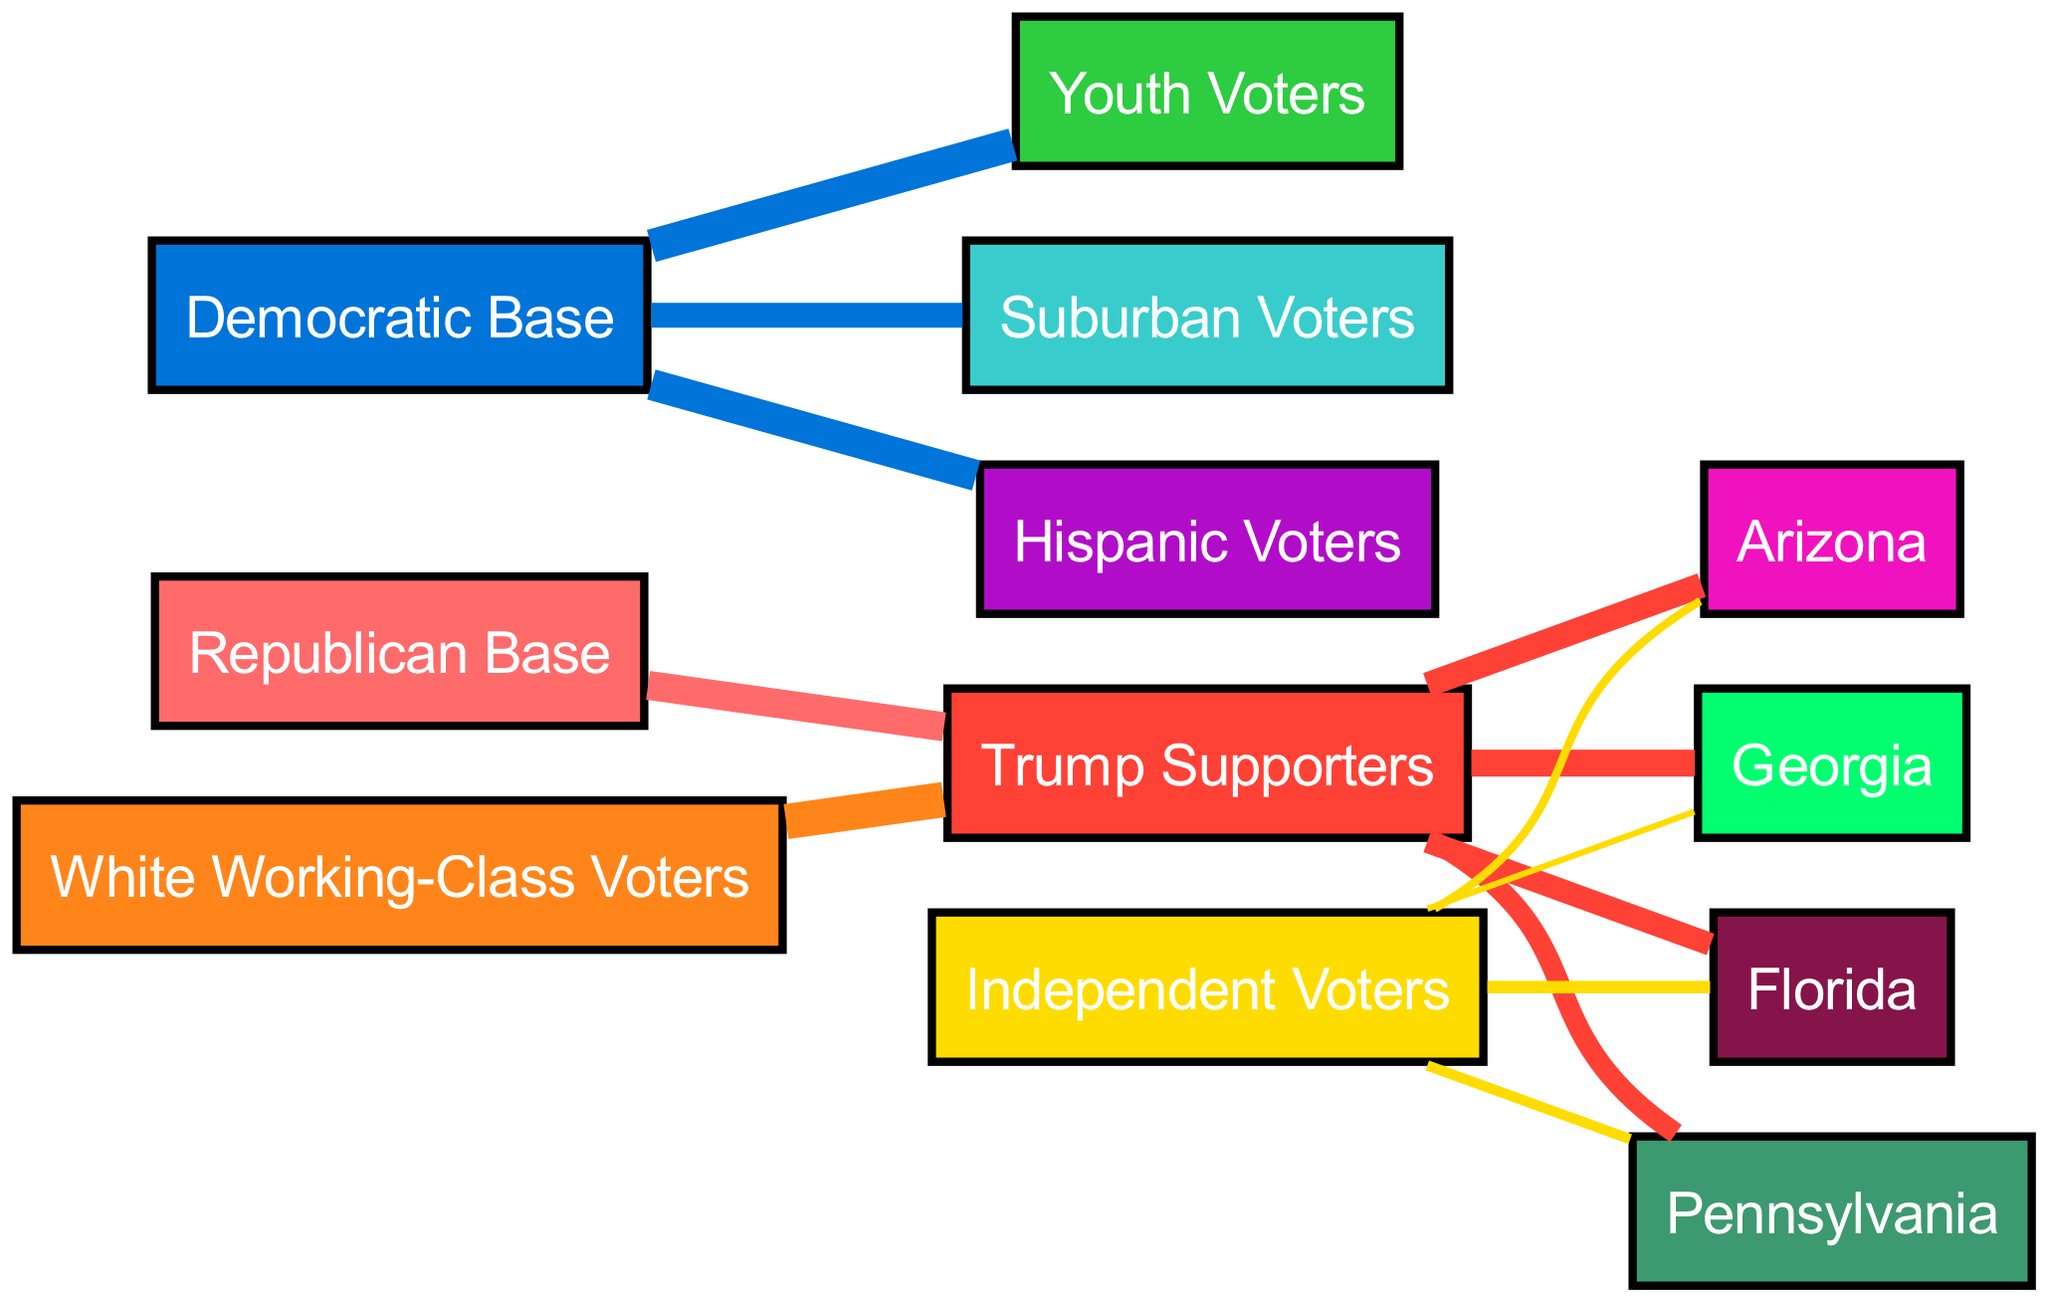What percentage of the Republican Base supports Trump Supporters? The diagram indicates a flow from the "Republican Base" to "Trump Supporters" with a value of 70, meaning 70% of the Republican Base supports Trump Supporters.
Answer: 70 How many key swing states are represented in this diagram? The nodes for key swing states are Florida, Pennsylvania, Arizona, and Georgia, totaling four states represented in the diagram.
Answer: 4 Which group has the highest flow to Florida from Trump Supporters? The flow from "Trump Supporters" to "Florida" is denoted by a value of 55, indicating that the highest support going to Florida from Trump Supporters comes from this group.
Answer: Trump Supporters What is the flow value of Independent Voters to Georgia? The value shown in the diagram from "Independent Voters" to "Georgia" is 15, indicating that 15% of Independent Voters show this flow to Georgia.
Answer: 15 Which demographic has the strongest support for the Democratic Base? The diagram indicates "Youth Voters," "Hispanic Voters," and "Suburban Voters" all flowing from the "Democratic Base." Among these, "Youth Voters" has the highest flow at 80.
Answer: Youth Voters Which demographic has the highest flow to Trump Supporters? The strongest demographic support for "Trump Supporters" comes from "White Working-Class Voters," with a very high flow value of 85, indicating this is the highest compared to other demographics.
Answer: White Working-Class Voters What is the total flow of Trump Supporters to Georgia? The diagram indicates a flow of 65 from "Trump Supporters" to "Georgia," showing the amount directly connecting these two nodes.
Answer: 65 What color represents Hispanic Voters in the diagram? Referring to the color scheme in the diagram, "Hispanic Voters" is represented in purple (#B10DC9).
Answer: Purple What is the combined value of support from Independent Voters to all swing states? The values from Independent Voters to Florida (30), Pennsylvania (25), Arizona (20), and Georgia (15) can be summed up: 30+25+20+15 = 90.
Answer: 90 